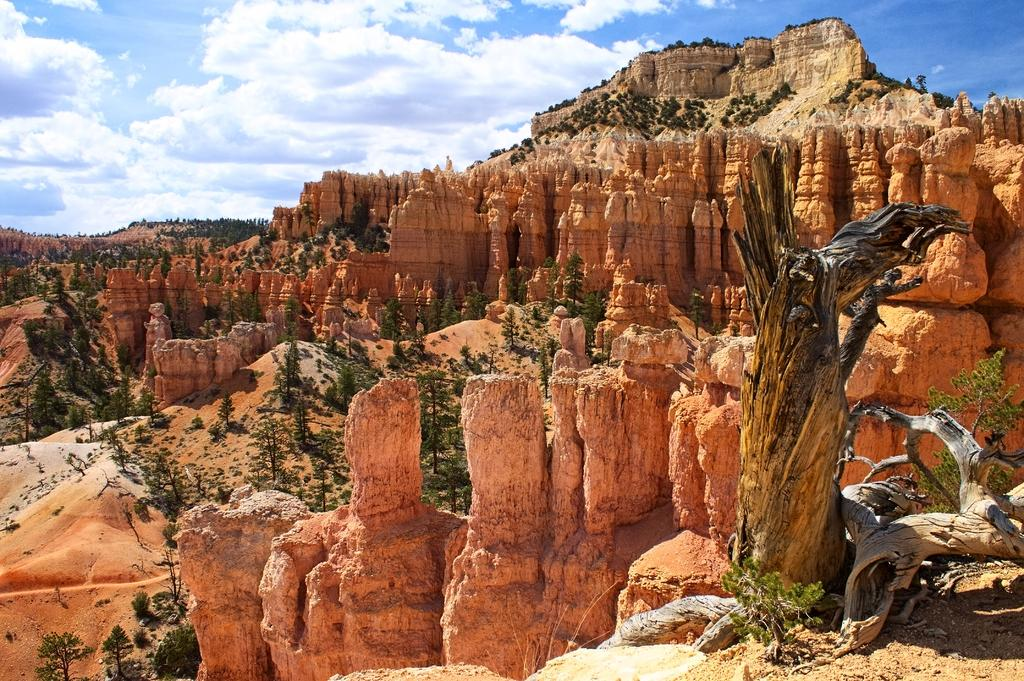What type of vegetation can be seen in the image? There is grass, plants, and trees visible in the image. What part of the trees can be seen in the image? Tree trunks are visible in the image. What type of geographical feature is present in the image? There are mountains in the image. What architectural elements can be seen in the image? Pillars are present in the image. What type of ground surface is visible in the image? Sand is visible in the image. What part of the natural environment is visible in the image? The sky is visible in the image. What can be inferred about the weather during the time the image was taken? The image was likely taken during a sunny day. Where is the friend's nest located in the image? There is no friend or nest present in the image. What type of cabbage is growing in the sandy area of the image? There is no cabbage visible in the image. 